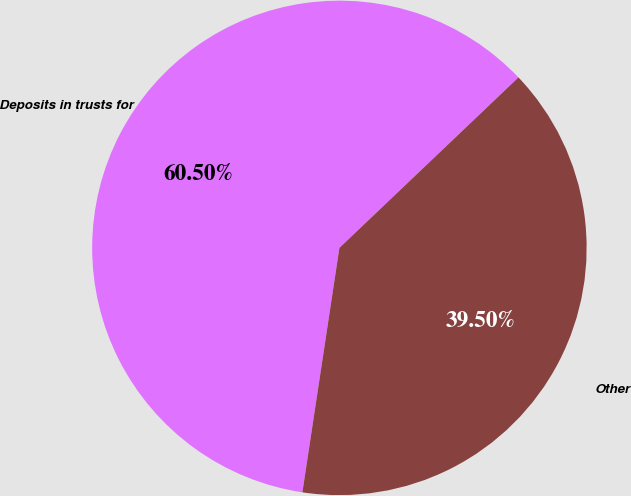Convert chart to OTSL. <chart><loc_0><loc_0><loc_500><loc_500><pie_chart><fcel>Deposits in trusts for<fcel>Other<nl><fcel>60.5%<fcel>39.5%<nl></chart> 